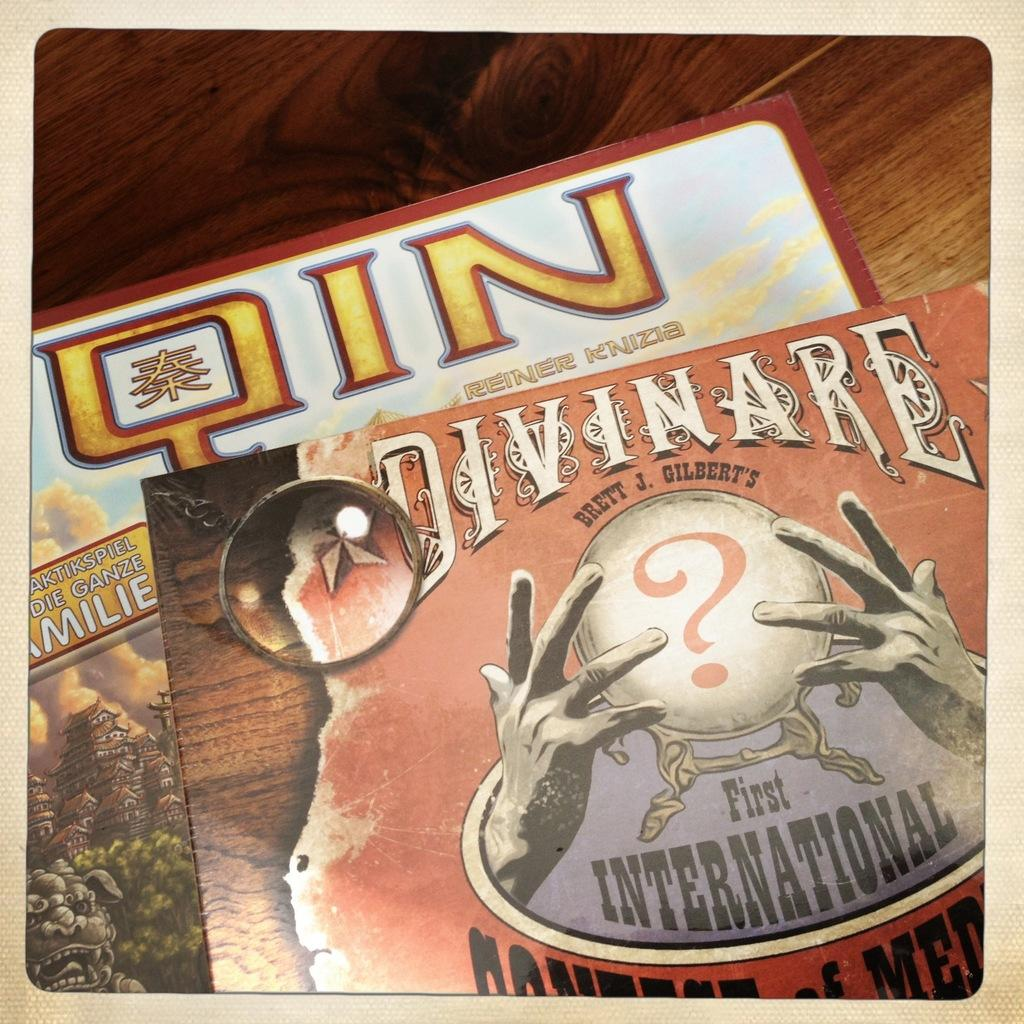Provide a one-sentence caption for the provided image. Cover for Divineare on top of abook titled "QIN". 